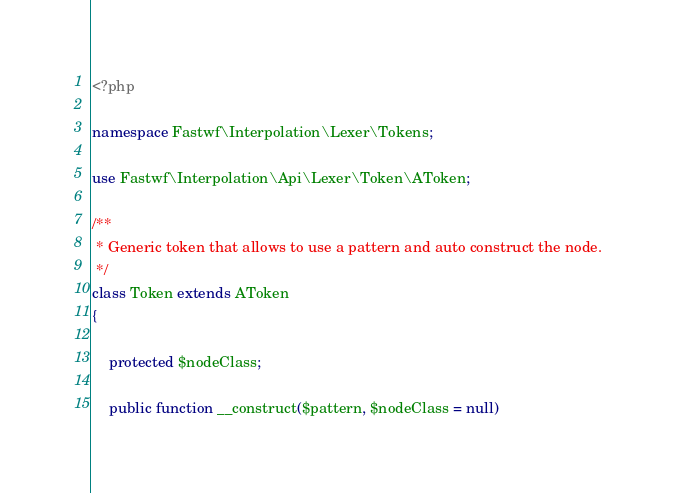<code> <loc_0><loc_0><loc_500><loc_500><_PHP_><?php

namespace Fastwf\Interpolation\Lexer\Tokens;

use Fastwf\Interpolation\Api\Lexer\Token\AToken;

/**
 * Generic token that allows to use a pattern and auto construct the node.
 */
class Token extends AToken
{

    protected $nodeClass;

    public function __construct($pattern, $nodeClass = null)</code> 